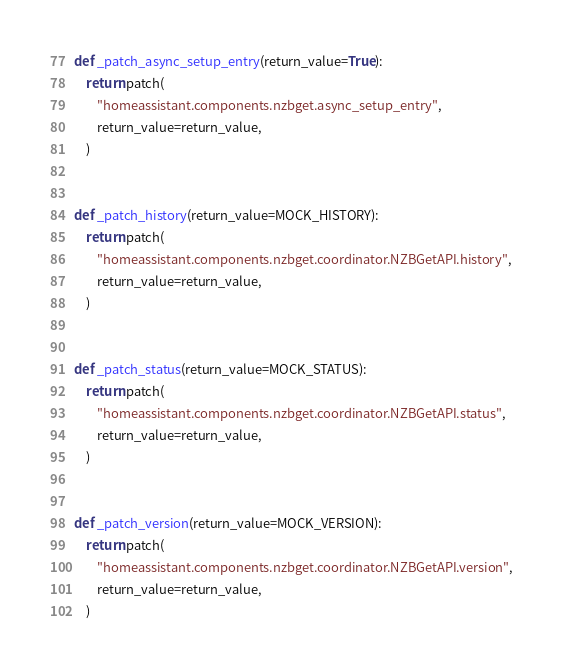<code> <loc_0><loc_0><loc_500><loc_500><_Python_>def _patch_async_setup_entry(return_value=True):
    return patch(
        "homeassistant.components.nzbget.async_setup_entry",
        return_value=return_value,
    )


def _patch_history(return_value=MOCK_HISTORY):
    return patch(
        "homeassistant.components.nzbget.coordinator.NZBGetAPI.history",
        return_value=return_value,
    )


def _patch_status(return_value=MOCK_STATUS):
    return patch(
        "homeassistant.components.nzbget.coordinator.NZBGetAPI.status",
        return_value=return_value,
    )


def _patch_version(return_value=MOCK_VERSION):
    return patch(
        "homeassistant.components.nzbget.coordinator.NZBGetAPI.version",
        return_value=return_value,
    )
</code> 